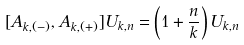Convert formula to latex. <formula><loc_0><loc_0><loc_500><loc_500>[ { A } _ { k , ( - ) } , { A } _ { k , ( + ) } ] U _ { k , n } = \left ( 1 + \frac { n } { k } \right ) U _ { k , n }</formula> 